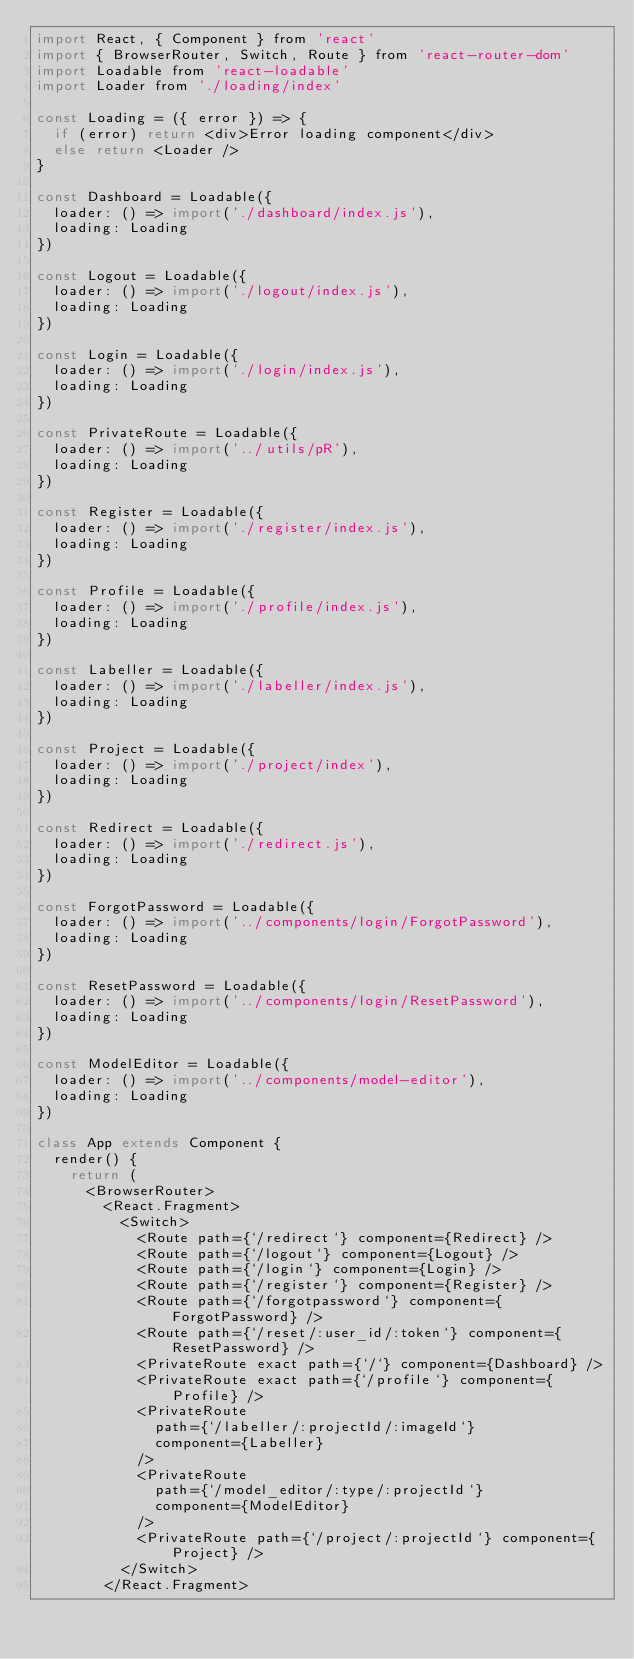<code> <loc_0><loc_0><loc_500><loc_500><_JavaScript_>import React, { Component } from 'react'
import { BrowserRouter, Switch, Route } from 'react-router-dom'
import Loadable from 'react-loadable'
import Loader from './loading/index'

const Loading = ({ error }) => {
  if (error) return <div>Error loading component</div>
  else return <Loader />
}

const Dashboard = Loadable({
  loader: () => import('./dashboard/index.js'),
  loading: Loading
})

const Logout = Loadable({
  loader: () => import('./logout/index.js'),
  loading: Loading
})

const Login = Loadable({
  loader: () => import('./login/index.js'),
  loading: Loading
})

const PrivateRoute = Loadable({
  loader: () => import('../utils/pR'),
  loading: Loading
})

const Register = Loadable({
  loader: () => import('./register/index.js'),
  loading: Loading
})

const Profile = Loadable({
  loader: () => import('./profile/index.js'),
  loading: Loading
})

const Labeller = Loadable({
  loader: () => import('./labeller/index.js'),
  loading: Loading
})

const Project = Loadable({
  loader: () => import('./project/index'),
  loading: Loading
})

const Redirect = Loadable({
  loader: () => import('./redirect.js'),
  loading: Loading
})

const ForgotPassword = Loadable({
  loader: () => import('../components/login/ForgotPassword'),
  loading: Loading
})

const ResetPassword = Loadable({
  loader: () => import('../components/login/ResetPassword'),
  loading: Loading
})

const ModelEditor = Loadable({
  loader: () => import('../components/model-editor'),
  loading: Loading
})

class App extends Component {
  render() {
    return (
      <BrowserRouter>
        <React.Fragment>
          <Switch>
            <Route path={`/redirect`} component={Redirect} />
            <Route path={`/logout`} component={Logout} />
            <Route path={`/login`} component={Login} />
            <Route path={`/register`} component={Register} />
            <Route path={`/forgotpassword`} component={ForgotPassword} />
            <Route path={`/reset/:user_id/:token`} component={ResetPassword} />
            <PrivateRoute exact path={`/`} component={Dashboard} />
            <PrivateRoute exact path={`/profile`} component={Profile} />
            <PrivateRoute
              path={`/labeller/:projectId/:imageId`}
              component={Labeller}
            />
            <PrivateRoute
              path={`/model_editor/:type/:projectId`}
              component={ModelEditor}
            />
            <PrivateRoute path={`/project/:projectId`} component={Project} />
          </Switch>
        </React.Fragment></code> 